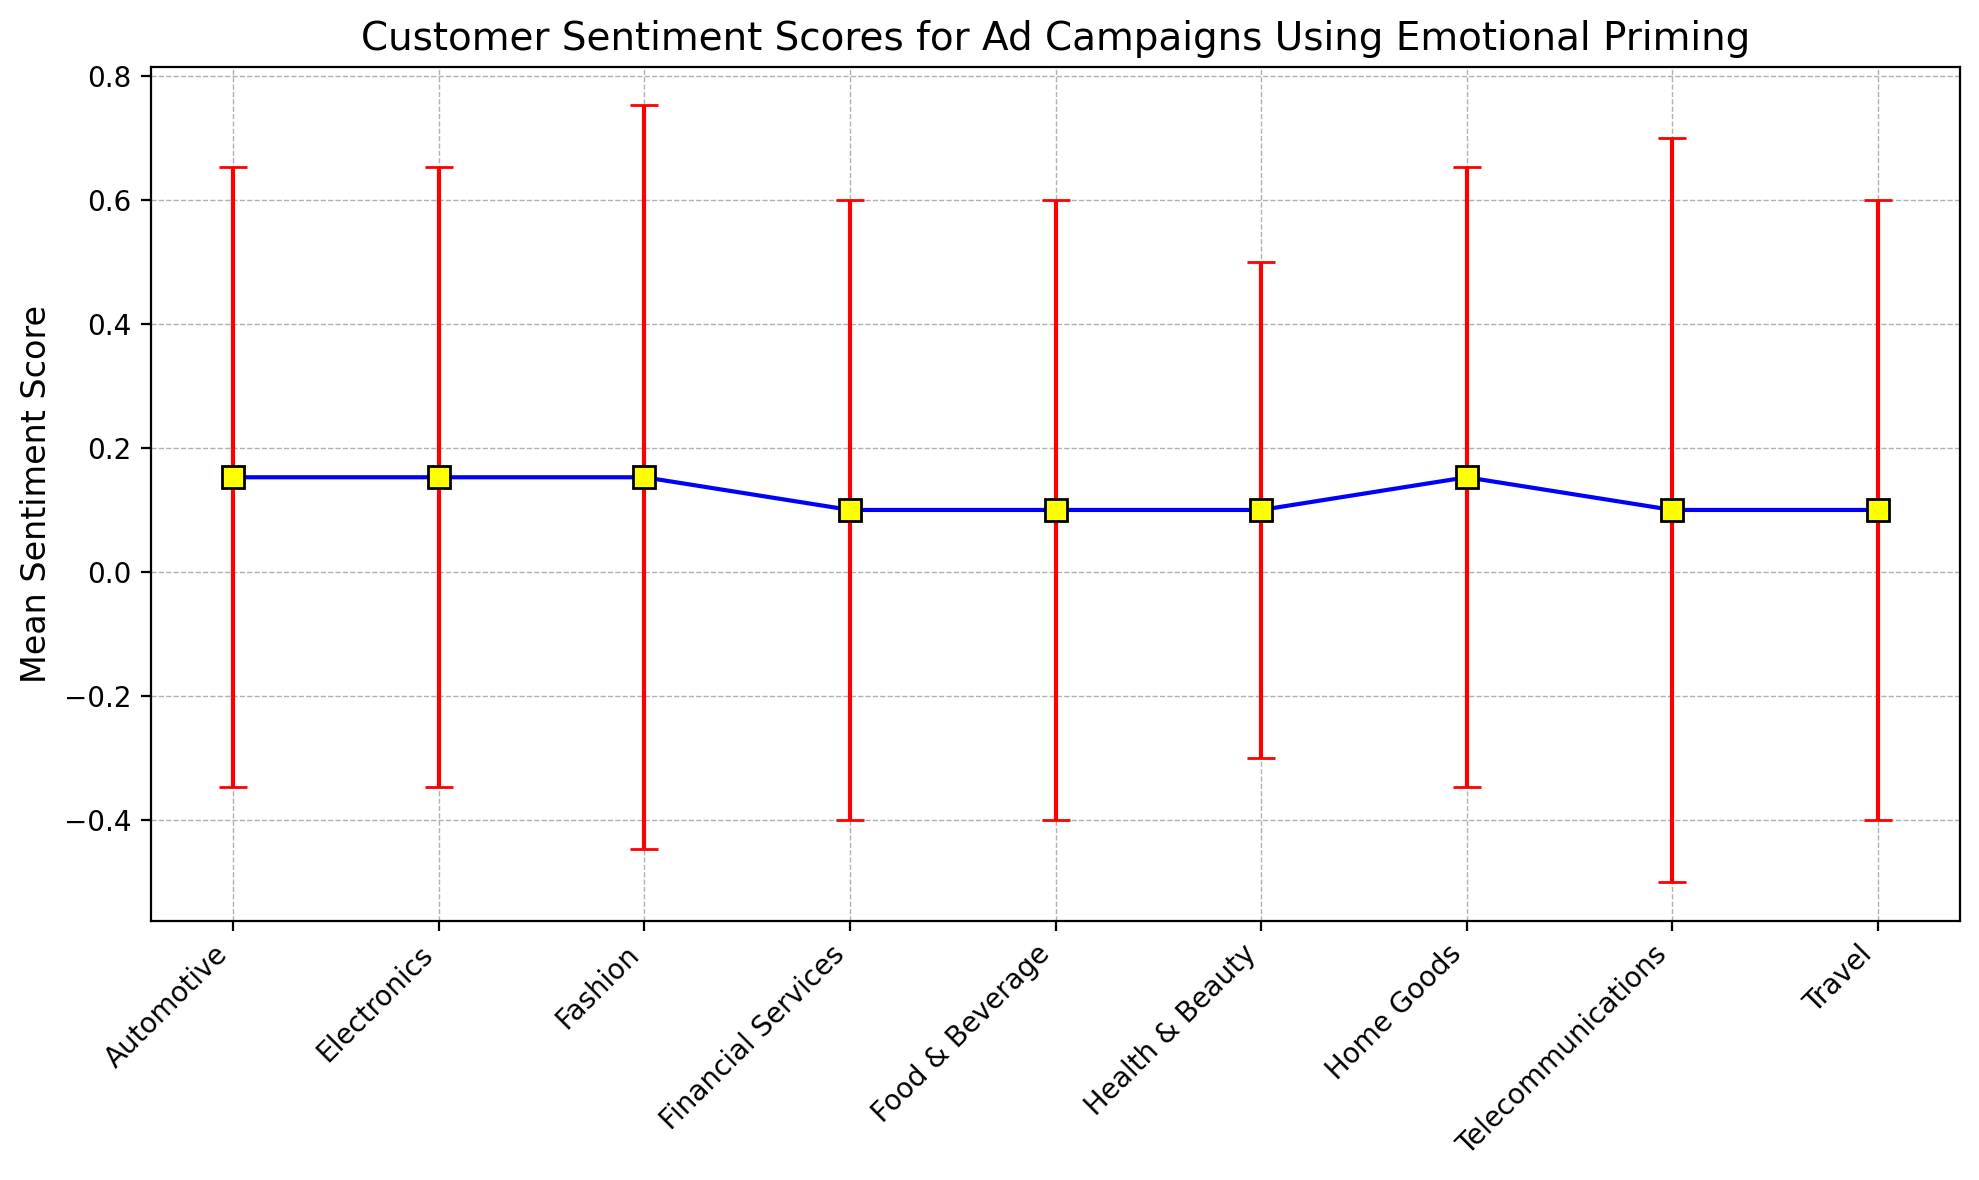Which product category has the highest mean sentiment score? We need to look at the error bars and determine the mean sentiment scores for each product category. The highest point on the y-axis will indicate the product category with the highest mean sentiment score.
Answer: Health & Beauty Which product category shows the largest error bar? The length of the error bar indicates the standard deviation. We need to identify the category with the longest red vertical line representing the error.
Answer: Fashion What is the difference in mean sentiment scores between the highest and the lowest scored product categories? First, identify the product category with the highest mean sentiment score (Health & Beauty) and the one with the lowest mean sentiment score (Fashion). Calculate the difference between these two scores.
Answer: 0.85 On average, do product categories have mean sentiment scores greater than 8? Calculate the overall average of the mean sentiment scores of all the product categories and check if the result is greater than 8.
Answer: Yes Which product category has the most consistent sentiment scores based on the error bars? Consistency is indicated by smaller error bars. We need to find the product category with the shortest error bars, representing the smallest standard deviations.
Answer: Health & Beauty Is there any product category with an average sentiment score exactly equal to 8.0? Examine the figure for mean sentiment scores that are exactly 8.0, considering the vertical positioning of the points and error bars.
Answer: Yes, Automotive How does the mean sentiment score of Fashion compare to Telecommunications? Look at the mean sentiment scores of both Fashion and Telecommunications on the y-axis of the chart and compare them.
Answer: Telecommunications is slightly higher Which category’s mean sentiment score is closest to 8.1? Identify the mean sentiment scores of each category and find the one nearest to 8.1 along the y-axis.
Answer: Home Goods, Automotive Among Electronics, Fashion, and Automotive, which has the highest mean sentiment score? Compare the average sentiment scores of Electronics, Fashion, and Automotive by looking at their positions on the y-axis.
Answer: Electronics 